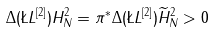Convert formula to latex. <formula><loc_0><loc_0><loc_500><loc_500>\Delta ( \L L ^ { [ 2 ] } ) H _ { N } ^ { 2 } = \pi ^ { * } \Delta ( \L L ^ { [ 2 ] } ) \widetilde { H } _ { N } ^ { 2 } > 0</formula> 